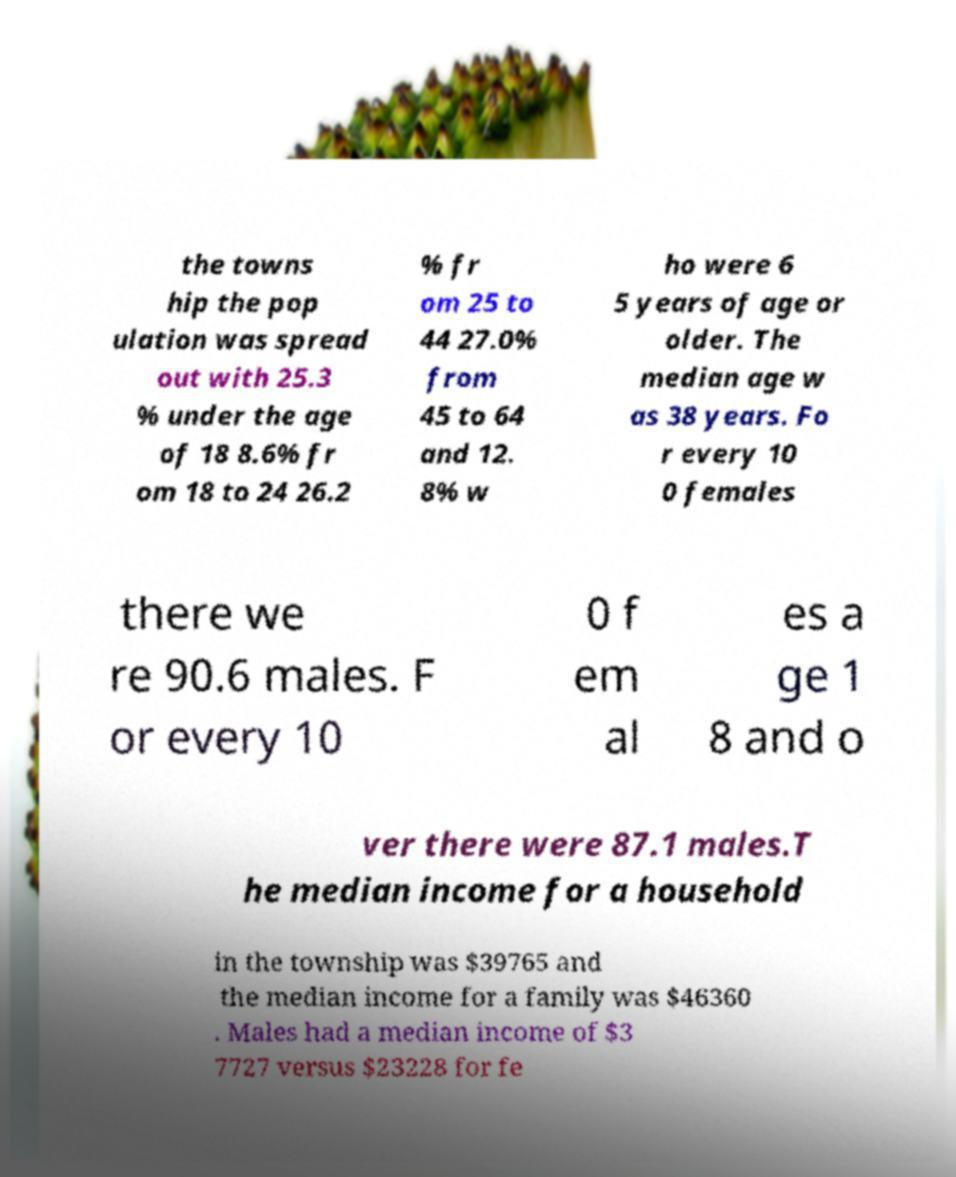Can you accurately transcribe the text from the provided image for me? the towns hip the pop ulation was spread out with 25.3 % under the age of 18 8.6% fr om 18 to 24 26.2 % fr om 25 to 44 27.0% from 45 to 64 and 12. 8% w ho were 6 5 years of age or older. The median age w as 38 years. Fo r every 10 0 females there we re 90.6 males. F or every 10 0 f em al es a ge 1 8 and o ver there were 87.1 males.T he median income for a household in the township was $39765 and the median income for a family was $46360 . Males had a median income of $3 7727 versus $23228 for fe 